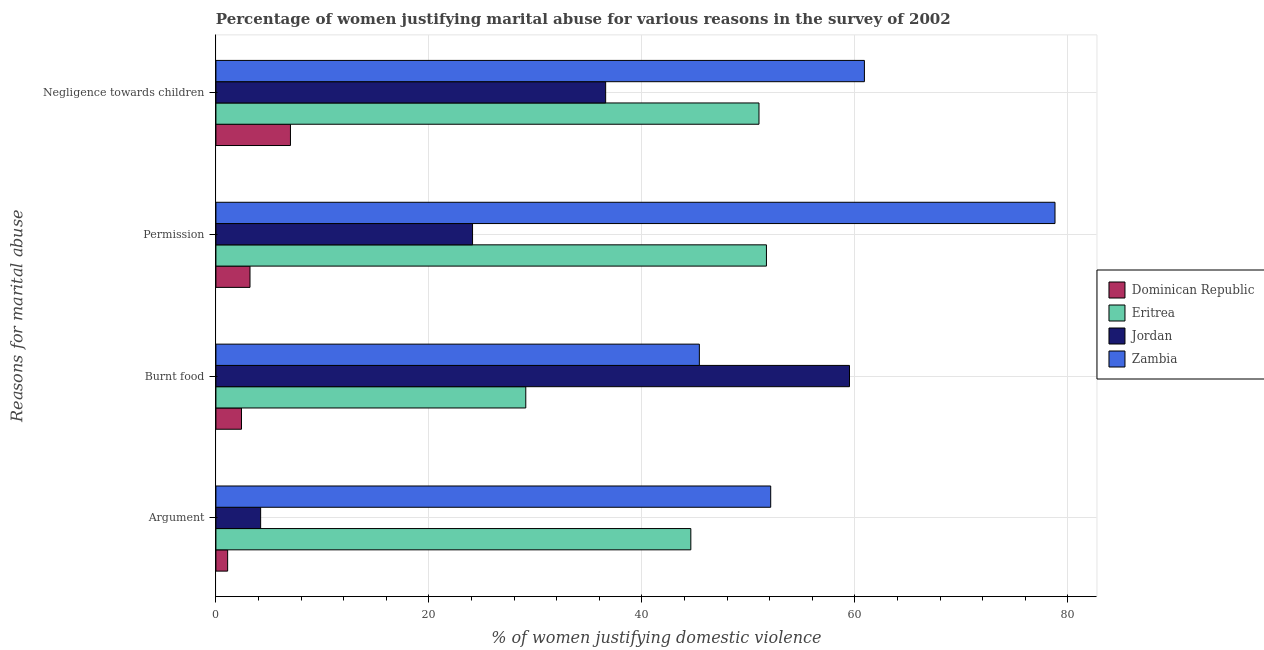How many groups of bars are there?
Offer a terse response. 4. Are the number of bars on each tick of the Y-axis equal?
Ensure brevity in your answer.  Yes. How many bars are there on the 3rd tick from the bottom?
Provide a short and direct response. 4. What is the label of the 3rd group of bars from the top?
Give a very brief answer. Burnt food. Across all countries, what is the maximum percentage of women justifying abuse for going without permission?
Offer a very short reply. 78.8. In which country was the percentage of women justifying abuse for showing negligence towards children maximum?
Offer a terse response. Zambia. In which country was the percentage of women justifying abuse for going without permission minimum?
Your response must be concise. Dominican Republic. What is the total percentage of women justifying abuse in the case of an argument in the graph?
Your answer should be compact. 102. What is the difference between the percentage of women justifying abuse for showing negligence towards children in Zambia and that in Dominican Republic?
Provide a succinct answer. 53.9. What is the difference between the percentage of women justifying abuse in the case of an argument in Zambia and the percentage of women justifying abuse for showing negligence towards children in Dominican Republic?
Your response must be concise. 45.1. What is the average percentage of women justifying abuse for burning food per country?
Provide a short and direct response. 34.1. What is the difference between the percentage of women justifying abuse in the case of an argument and percentage of women justifying abuse for showing negligence towards children in Zambia?
Offer a very short reply. -8.8. In how many countries, is the percentage of women justifying abuse for showing negligence towards children greater than 24 %?
Provide a succinct answer. 3. What is the ratio of the percentage of women justifying abuse for burning food in Jordan to that in Dominican Republic?
Offer a very short reply. 24.79. What is the difference between the highest and the second highest percentage of women justifying abuse for burning food?
Give a very brief answer. 14.1. What is the difference between the highest and the lowest percentage of women justifying abuse in the case of an argument?
Offer a terse response. 51. What does the 4th bar from the top in Negligence towards children represents?
Your answer should be very brief. Dominican Republic. What does the 3rd bar from the bottom in Argument represents?
Keep it short and to the point. Jordan. Is it the case that in every country, the sum of the percentage of women justifying abuse in the case of an argument and percentage of women justifying abuse for burning food is greater than the percentage of women justifying abuse for going without permission?
Your answer should be compact. Yes. How many bars are there?
Give a very brief answer. 16. What is the difference between two consecutive major ticks on the X-axis?
Make the answer very short. 20. Are the values on the major ticks of X-axis written in scientific E-notation?
Give a very brief answer. No. Does the graph contain any zero values?
Your response must be concise. No. Does the graph contain grids?
Offer a terse response. Yes. Where does the legend appear in the graph?
Provide a short and direct response. Center right. How are the legend labels stacked?
Your response must be concise. Vertical. What is the title of the graph?
Offer a terse response. Percentage of women justifying marital abuse for various reasons in the survey of 2002. Does "Guyana" appear as one of the legend labels in the graph?
Your response must be concise. No. What is the label or title of the X-axis?
Offer a very short reply. % of women justifying domestic violence. What is the label or title of the Y-axis?
Your answer should be compact. Reasons for marital abuse. What is the % of women justifying domestic violence in Dominican Republic in Argument?
Provide a short and direct response. 1.1. What is the % of women justifying domestic violence of Eritrea in Argument?
Offer a very short reply. 44.6. What is the % of women justifying domestic violence in Jordan in Argument?
Provide a short and direct response. 4.2. What is the % of women justifying domestic violence of Zambia in Argument?
Provide a short and direct response. 52.1. What is the % of women justifying domestic violence of Eritrea in Burnt food?
Keep it short and to the point. 29.1. What is the % of women justifying domestic violence in Jordan in Burnt food?
Give a very brief answer. 59.5. What is the % of women justifying domestic violence in Zambia in Burnt food?
Keep it short and to the point. 45.4. What is the % of women justifying domestic violence of Dominican Republic in Permission?
Make the answer very short. 3.2. What is the % of women justifying domestic violence in Eritrea in Permission?
Offer a terse response. 51.7. What is the % of women justifying domestic violence in Jordan in Permission?
Make the answer very short. 24.1. What is the % of women justifying domestic violence of Zambia in Permission?
Offer a very short reply. 78.8. What is the % of women justifying domestic violence of Dominican Republic in Negligence towards children?
Your response must be concise. 7. What is the % of women justifying domestic violence in Eritrea in Negligence towards children?
Your answer should be compact. 51. What is the % of women justifying domestic violence of Jordan in Negligence towards children?
Your answer should be compact. 36.6. What is the % of women justifying domestic violence in Zambia in Negligence towards children?
Your response must be concise. 60.9. Across all Reasons for marital abuse, what is the maximum % of women justifying domestic violence of Dominican Republic?
Your response must be concise. 7. Across all Reasons for marital abuse, what is the maximum % of women justifying domestic violence of Eritrea?
Your answer should be very brief. 51.7. Across all Reasons for marital abuse, what is the maximum % of women justifying domestic violence in Jordan?
Make the answer very short. 59.5. Across all Reasons for marital abuse, what is the maximum % of women justifying domestic violence in Zambia?
Your response must be concise. 78.8. Across all Reasons for marital abuse, what is the minimum % of women justifying domestic violence of Dominican Republic?
Your answer should be very brief. 1.1. Across all Reasons for marital abuse, what is the minimum % of women justifying domestic violence in Eritrea?
Your answer should be very brief. 29.1. Across all Reasons for marital abuse, what is the minimum % of women justifying domestic violence of Zambia?
Your answer should be compact. 45.4. What is the total % of women justifying domestic violence of Eritrea in the graph?
Your answer should be very brief. 176.4. What is the total % of women justifying domestic violence in Jordan in the graph?
Your answer should be compact. 124.4. What is the total % of women justifying domestic violence in Zambia in the graph?
Offer a very short reply. 237.2. What is the difference between the % of women justifying domestic violence in Dominican Republic in Argument and that in Burnt food?
Offer a terse response. -1.3. What is the difference between the % of women justifying domestic violence of Jordan in Argument and that in Burnt food?
Give a very brief answer. -55.3. What is the difference between the % of women justifying domestic violence of Jordan in Argument and that in Permission?
Offer a terse response. -19.9. What is the difference between the % of women justifying domestic violence in Zambia in Argument and that in Permission?
Your response must be concise. -26.7. What is the difference between the % of women justifying domestic violence of Dominican Republic in Argument and that in Negligence towards children?
Offer a very short reply. -5.9. What is the difference between the % of women justifying domestic violence of Eritrea in Argument and that in Negligence towards children?
Make the answer very short. -6.4. What is the difference between the % of women justifying domestic violence in Jordan in Argument and that in Negligence towards children?
Your answer should be compact. -32.4. What is the difference between the % of women justifying domestic violence of Dominican Republic in Burnt food and that in Permission?
Provide a short and direct response. -0.8. What is the difference between the % of women justifying domestic violence of Eritrea in Burnt food and that in Permission?
Offer a terse response. -22.6. What is the difference between the % of women justifying domestic violence in Jordan in Burnt food and that in Permission?
Offer a terse response. 35.4. What is the difference between the % of women justifying domestic violence in Zambia in Burnt food and that in Permission?
Ensure brevity in your answer.  -33.4. What is the difference between the % of women justifying domestic violence of Dominican Republic in Burnt food and that in Negligence towards children?
Your response must be concise. -4.6. What is the difference between the % of women justifying domestic violence in Eritrea in Burnt food and that in Negligence towards children?
Give a very brief answer. -21.9. What is the difference between the % of women justifying domestic violence in Jordan in Burnt food and that in Negligence towards children?
Give a very brief answer. 22.9. What is the difference between the % of women justifying domestic violence of Zambia in Burnt food and that in Negligence towards children?
Keep it short and to the point. -15.5. What is the difference between the % of women justifying domestic violence in Dominican Republic in Permission and that in Negligence towards children?
Your response must be concise. -3.8. What is the difference between the % of women justifying domestic violence of Jordan in Permission and that in Negligence towards children?
Offer a terse response. -12.5. What is the difference between the % of women justifying domestic violence in Dominican Republic in Argument and the % of women justifying domestic violence in Jordan in Burnt food?
Provide a succinct answer. -58.4. What is the difference between the % of women justifying domestic violence of Dominican Republic in Argument and the % of women justifying domestic violence of Zambia in Burnt food?
Provide a succinct answer. -44.3. What is the difference between the % of women justifying domestic violence in Eritrea in Argument and the % of women justifying domestic violence in Jordan in Burnt food?
Offer a terse response. -14.9. What is the difference between the % of women justifying domestic violence in Jordan in Argument and the % of women justifying domestic violence in Zambia in Burnt food?
Make the answer very short. -41.2. What is the difference between the % of women justifying domestic violence of Dominican Republic in Argument and the % of women justifying domestic violence of Eritrea in Permission?
Your answer should be compact. -50.6. What is the difference between the % of women justifying domestic violence of Dominican Republic in Argument and the % of women justifying domestic violence of Zambia in Permission?
Provide a short and direct response. -77.7. What is the difference between the % of women justifying domestic violence in Eritrea in Argument and the % of women justifying domestic violence in Jordan in Permission?
Your response must be concise. 20.5. What is the difference between the % of women justifying domestic violence of Eritrea in Argument and the % of women justifying domestic violence of Zambia in Permission?
Ensure brevity in your answer.  -34.2. What is the difference between the % of women justifying domestic violence in Jordan in Argument and the % of women justifying domestic violence in Zambia in Permission?
Keep it short and to the point. -74.6. What is the difference between the % of women justifying domestic violence of Dominican Republic in Argument and the % of women justifying domestic violence of Eritrea in Negligence towards children?
Provide a short and direct response. -49.9. What is the difference between the % of women justifying domestic violence in Dominican Republic in Argument and the % of women justifying domestic violence in Jordan in Negligence towards children?
Ensure brevity in your answer.  -35.5. What is the difference between the % of women justifying domestic violence of Dominican Republic in Argument and the % of women justifying domestic violence of Zambia in Negligence towards children?
Provide a succinct answer. -59.8. What is the difference between the % of women justifying domestic violence in Eritrea in Argument and the % of women justifying domestic violence in Jordan in Negligence towards children?
Provide a succinct answer. 8. What is the difference between the % of women justifying domestic violence in Eritrea in Argument and the % of women justifying domestic violence in Zambia in Negligence towards children?
Offer a terse response. -16.3. What is the difference between the % of women justifying domestic violence of Jordan in Argument and the % of women justifying domestic violence of Zambia in Negligence towards children?
Make the answer very short. -56.7. What is the difference between the % of women justifying domestic violence in Dominican Republic in Burnt food and the % of women justifying domestic violence in Eritrea in Permission?
Provide a succinct answer. -49.3. What is the difference between the % of women justifying domestic violence of Dominican Republic in Burnt food and the % of women justifying domestic violence of Jordan in Permission?
Make the answer very short. -21.7. What is the difference between the % of women justifying domestic violence of Dominican Republic in Burnt food and the % of women justifying domestic violence of Zambia in Permission?
Ensure brevity in your answer.  -76.4. What is the difference between the % of women justifying domestic violence of Eritrea in Burnt food and the % of women justifying domestic violence of Jordan in Permission?
Your answer should be very brief. 5. What is the difference between the % of women justifying domestic violence in Eritrea in Burnt food and the % of women justifying domestic violence in Zambia in Permission?
Offer a terse response. -49.7. What is the difference between the % of women justifying domestic violence of Jordan in Burnt food and the % of women justifying domestic violence of Zambia in Permission?
Make the answer very short. -19.3. What is the difference between the % of women justifying domestic violence in Dominican Republic in Burnt food and the % of women justifying domestic violence in Eritrea in Negligence towards children?
Make the answer very short. -48.6. What is the difference between the % of women justifying domestic violence of Dominican Republic in Burnt food and the % of women justifying domestic violence of Jordan in Negligence towards children?
Keep it short and to the point. -34.2. What is the difference between the % of women justifying domestic violence of Dominican Republic in Burnt food and the % of women justifying domestic violence of Zambia in Negligence towards children?
Offer a very short reply. -58.5. What is the difference between the % of women justifying domestic violence of Eritrea in Burnt food and the % of women justifying domestic violence of Jordan in Negligence towards children?
Ensure brevity in your answer.  -7.5. What is the difference between the % of women justifying domestic violence of Eritrea in Burnt food and the % of women justifying domestic violence of Zambia in Negligence towards children?
Your response must be concise. -31.8. What is the difference between the % of women justifying domestic violence in Dominican Republic in Permission and the % of women justifying domestic violence in Eritrea in Negligence towards children?
Your answer should be compact. -47.8. What is the difference between the % of women justifying domestic violence of Dominican Republic in Permission and the % of women justifying domestic violence of Jordan in Negligence towards children?
Provide a short and direct response. -33.4. What is the difference between the % of women justifying domestic violence in Dominican Republic in Permission and the % of women justifying domestic violence in Zambia in Negligence towards children?
Give a very brief answer. -57.7. What is the difference between the % of women justifying domestic violence of Eritrea in Permission and the % of women justifying domestic violence of Jordan in Negligence towards children?
Your response must be concise. 15.1. What is the difference between the % of women justifying domestic violence of Jordan in Permission and the % of women justifying domestic violence of Zambia in Negligence towards children?
Make the answer very short. -36.8. What is the average % of women justifying domestic violence in Dominican Republic per Reasons for marital abuse?
Give a very brief answer. 3.42. What is the average % of women justifying domestic violence of Eritrea per Reasons for marital abuse?
Make the answer very short. 44.1. What is the average % of women justifying domestic violence of Jordan per Reasons for marital abuse?
Offer a terse response. 31.1. What is the average % of women justifying domestic violence in Zambia per Reasons for marital abuse?
Your answer should be very brief. 59.3. What is the difference between the % of women justifying domestic violence in Dominican Republic and % of women justifying domestic violence in Eritrea in Argument?
Ensure brevity in your answer.  -43.5. What is the difference between the % of women justifying domestic violence in Dominican Republic and % of women justifying domestic violence in Jordan in Argument?
Ensure brevity in your answer.  -3.1. What is the difference between the % of women justifying domestic violence of Dominican Republic and % of women justifying domestic violence of Zambia in Argument?
Provide a short and direct response. -51. What is the difference between the % of women justifying domestic violence in Eritrea and % of women justifying domestic violence in Jordan in Argument?
Offer a terse response. 40.4. What is the difference between the % of women justifying domestic violence of Jordan and % of women justifying domestic violence of Zambia in Argument?
Offer a terse response. -47.9. What is the difference between the % of women justifying domestic violence in Dominican Republic and % of women justifying domestic violence in Eritrea in Burnt food?
Offer a very short reply. -26.7. What is the difference between the % of women justifying domestic violence of Dominican Republic and % of women justifying domestic violence of Jordan in Burnt food?
Make the answer very short. -57.1. What is the difference between the % of women justifying domestic violence of Dominican Republic and % of women justifying domestic violence of Zambia in Burnt food?
Ensure brevity in your answer.  -43. What is the difference between the % of women justifying domestic violence in Eritrea and % of women justifying domestic violence in Jordan in Burnt food?
Your answer should be compact. -30.4. What is the difference between the % of women justifying domestic violence in Eritrea and % of women justifying domestic violence in Zambia in Burnt food?
Keep it short and to the point. -16.3. What is the difference between the % of women justifying domestic violence of Dominican Republic and % of women justifying domestic violence of Eritrea in Permission?
Offer a terse response. -48.5. What is the difference between the % of women justifying domestic violence of Dominican Republic and % of women justifying domestic violence of Jordan in Permission?
Offer a terse response. -20.9. What is the difference between the % of women justifying domestic violence of Dominican Republic and % of women justifying domestic violence of Zambia in Permission?
Provide a short and direct response. -75.6. What is the difference between the % of women justifying domestic violence of Eritrea and % of women justifying domestic violence of Jordan in Permission?
Keep it short and to the point. 27.6. What is the difference between the % of women justifying domestic violence of Eritrea and % of women justifying domestic violence of Zambia in Permission?
Offer a terse response. -27.1. What is the difference between the % of women justifying domestic violence in Jordan and % of women justifying domestic violence in Zambia in Permission?
Offer a terse response. -54.7. What is the difference between the % of women justifying domestic violence in Dominican Republic and % of women justifying domestic violence in Eritrea in Negligence towards children?
Offer a very short reply. -44. What is the difference between the % of women justifying domestic violence of Dominican Republic and % of women justifying domestic violence of Jordan in Negligence towards children?
Provide a short and direct response. -29.6. What is the difference between the % of women justifying domestic violence in Dominican Republic and % of women justifying domestic violence in Zambia in Negligence towards children?
Give a very brief answer. -53.9. What is the difference between the % of women justifying domestic violence of Eritrea and % of women justifying domestic violence of Jordan in Negligence towards children?
Your answer should be very brief. 14.4. What is the difference between the % of women justifying domestic violence of Eritrea and % of women justifying domestic violence of Zambia in Negligence towards children?
Provide a succinct answer. -9.9. What is the difference between the % of women justifying domestic violence in Jordan and % of women justifying domestic violence in Zambia in Negligence towards children?
Offer a very short reply. -24.3. What is the ratio of the % of women justifying domestic violence in Dominican Republic in Argument to that in Burnt food?
Your answer should be compact. 0.46. What is the ratio of the % of women justifying domestic violence in Eritrea in Argument to that in Burnt food?
Give a very brief answer. 1.53. What is the ratio of the % of women justifying domestic violence in Jordan in Argument to that in Burnt food?
Offer a very short reply. 0.07. What is the ratio of the % of women justifying domestic violence of Zambia in Argument to that in Burnt food?
Your answer should be compact. 1.15. What is the ratio of the % of women justifying domestic violence in Dominican Republic in Argument to that in Permission?
Ensure brevity in your answer.  0.34. What is the ratio of the % of women justifying domestic violence in Eritrea in Argument to that in Permission?
Make the answer very short. 0.86. What is the ratio of the % of women justifying domestic violence of Jordan in Argument to that in Permission?
Make the answer very short. 0.17. What is the ratio of the % of women justifying domestic violence of Zambia in Argument to that in Permission?
Give a very brief answer. 0.66. What is the ratio of the % of women justifying domestic violence of Dominican Republic in Argument to that in Negligence towards children?
Ensure brevity in your answer.  0.16. What is the ratio of the % of women justifying domestic violence of Eritrea in Argument to that in Negligence towards children?
Keep it short and to the point. 0.87. What is the ratio of the % of women justifying domestic violence of Jordan in Argument to that in Negligence towards children?
Keep it short and to the point. 0.11. What is the ratio of the % of women justifying domestic violence in Zambia in Argument to that in Negligence towards children?
Offer a very short reply. 0.86. What is the ratio of the % of women justifying domestic violence of Dominican Republic in Burnt food to that in Permission?
Your answer should be compact. 0.75. What is the ratio of the % of women justifying domestic violence in Eritrea in Burnt food to that in Permission?
Keep it short and to the point. 0.56. What is the ratio of the % of women justifying domestic violence in Jordan in Burnt food to that in Permission?
Ensure brevity in your answer.  2.47. What is the ratio of the % of women justifying domestic violence in Zambia in Burnt food to that in Permission?
Give a very brief answer. 0.58. What is the ratio of the % of women justifying domestic violence in Dominican Republic in Burnt food to that in Negligence towards children?
Offer a terse response. 0.34. What is the ratio of the % of women justifying domestic violence of Eritrea in Burnt food to that in Negligence towards children?
Your answer should be very brief. 0.57. What is the ratio of the % of women justifying domestic violence of Jordan in Burnt food to that in Negligence towards children?
Provide a short and direct response. 1.63. What is the ratio of the % of women justifying domestic violence of Zambia in Burnt food to that in Negligence towards children?
Provide a succinct answer. 0.75. What is the ratio of the % of women justifying domestic violence in Dominican Republic in Permission to that in Negligence towards children?
Your answer should be very brief. 0.46. What is the ratio of the % of women justifying domestic violence of Eritrea in Permission to that in Negligence towards children?
Ensure brevity in your answer.  1.01. What is the ratio of the % of women justifying domestic violence of Jordan in Permission to that in Negligence towards children?
Provide a succinct answer. 0.66. What is the ratio of the % of women justifying domestic violence of Zambia in Permission to that in Negligence towards children?
Your answer should be compact. 1.29. What is the difference between the highest and the second highest % of women justifying domestic violence of Eritrea?
Give a very brief answer. 0.7. What is the difference between the highest and the second highest % of women justifying domestic violence of Jordan?
Provide a short and direct response. 22.9. What is the difference between the highest and the lowest % of women justifying domestic violence in Eritrea?
Offer a very short reply. 22.6. What is the difference between the highest and the lowest % of women justifying domestic violence in Jordan?
Offer a very short reply. 55.3. What is the difference between the highest and the lowest % of women justifying domestic violence in Zambia?
Provide a succinct answer. 33.4. 